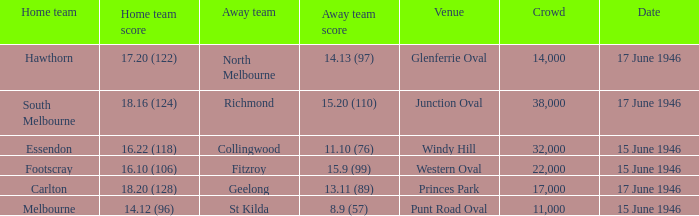On what date was a game played at Windy Hill? 15 June 1946. 